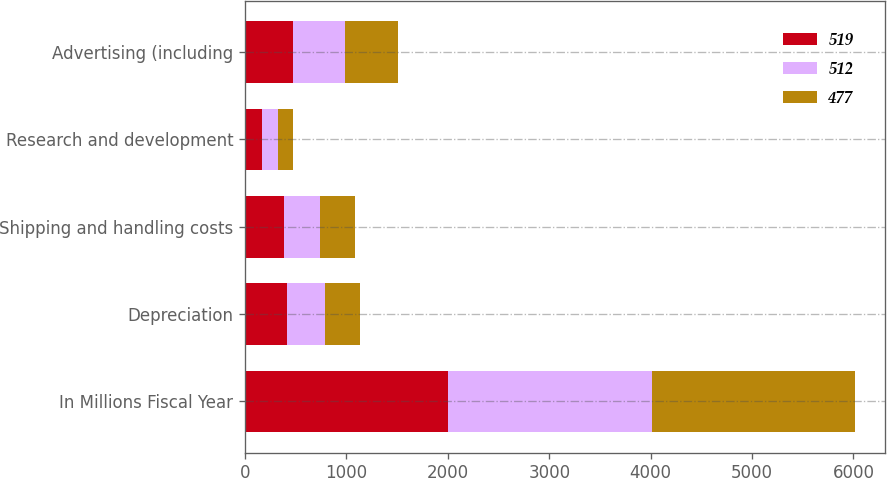Convert chart. <chart><loc_0><loc_0><loc_500><loc_500><stacked_bar_chart><ecel><fcel>In Millions Fiscal Year<fcel>Depreciation<fcel>Shipping and handling costs<fcel>Research and development<fcel>Advertising (including<nl><fcel>519<fcel>2005<fcel>415<fcel>388<fcel>168<fcel>477<nl><fcel>512<fcel>2004<fcel>376<fcel>352<fcel>158<fcel>512<nl><fcel>477<fcel>2003<fcel>347<fcel>345<fcel>149<fcel>519<nl></chart> 